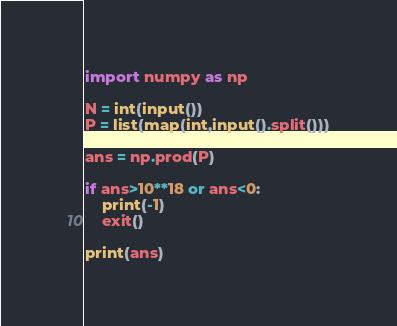<code> <loc_0><loc_0><loc_500><loc_500><_Python_>import numpy as np

N = int(input())
P = list(map(int,input().split()))

ans = np.prod(P)

if ans>10**18 or ans<0:
    print(-1)
    exit()

print(ans)</code> 